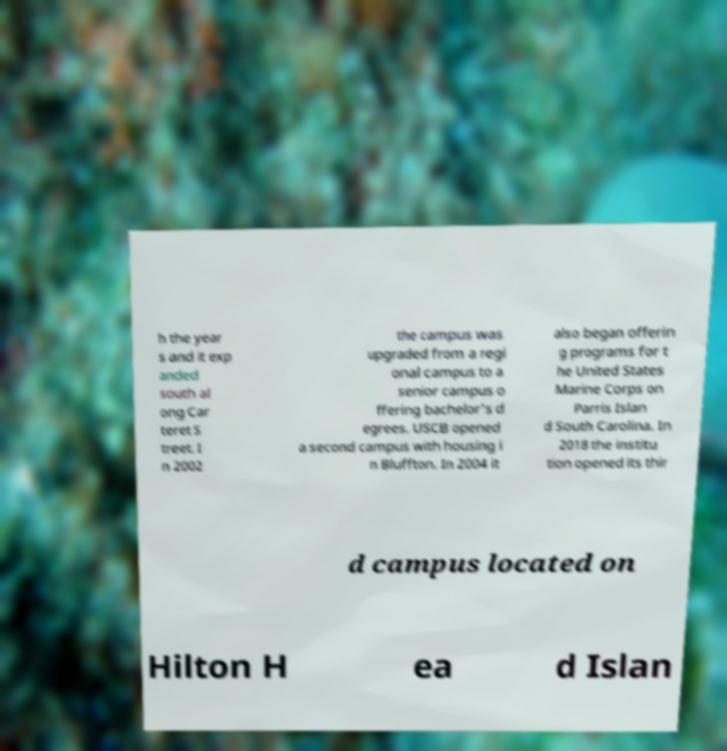There's text embedded in this image that I need extracted. Can you transcribe it verbatim? h the year s and it exp anded south al ong Car teret S treet. I n 2002 the campus was upgraded from a regi onal campus to a senior campus o ffering bachelor's d egrees. USCB opened a second campus with housing i n Bluffton. In 2004 it also began offerin g programs for t he United States Marine Corps on Parris Islan d South Carolina. In 2018 the institu tion opened its thir d campus located on Hilton H ea d Islan 